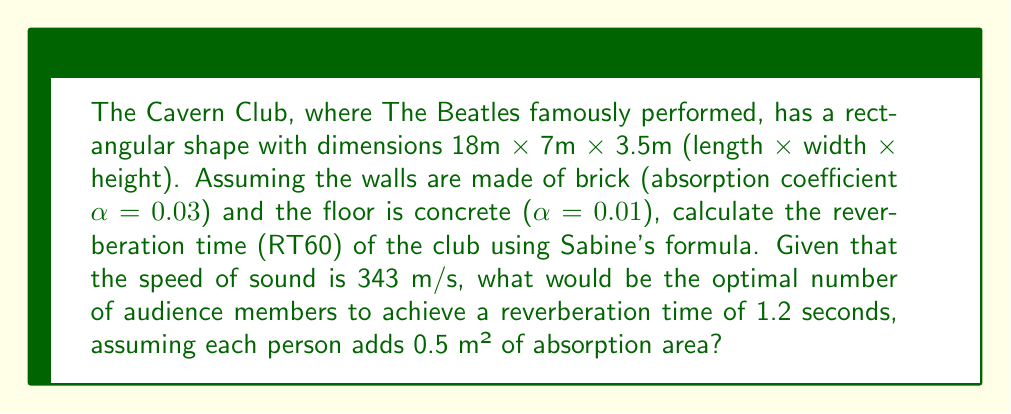Provide a solution to this math problem. Let's approach this step-by-step:

1) First, we need to calculate the total surface area of the room:
   $$S_{total} = 2(lw + lh + wh) = 2(18 \cdot 7 + 18 \cdot 3.5 + 7 \cdot 3.5) = 361 \text{ m}^2$$

2) Next, we calculate the volume of the room:
   $$V = l \cdot w \cdot h = 18 \cdot 7 \cdot 3.5 = 441 \text{ m}^3$$

3) The total absorption of the room without audience is:
   $$A_{room} = S_{walls} \cdot \alpha_{brick} + S_{floor} \cdot \alpha_{concrete}$$
   $$A_{room} = (361 - 18 \cdot 7) \cdot 0.03 + (18 \cdot 7) \cdot 0.01 = 7.59 \text{ m}^2$$

4) Sabine's formula for reverberation time is:
   $$RT60 = \frac{0.161 \cdot V}{A}$$
   where V is the volume and A is the total absorption.

5) We want RT60 = 1.2 seconds, so we can solve for the required total absorption:
   $$1.2 = \frac{0.161 \cdot 441}{A_{total}}$$
   $$A_{total} = \frac{0.161 \cdot 441}{1.2} = 59.135 \text{ m}^2$$

6) The additional absorption needed from the audience is:
   $$A_{audience} = A_{total} - A_{room} = 59.135 - 7.59 = 51.545 \text{ m}^2$$

7) Since each person adds 0.5 m² of absorption, the number of people needed is:
   $$N = \frac{A_{audience}}{0.5} = \frac{51.545}{0.5} \approx 103 \text{ people}$$
Answer: 103 people 